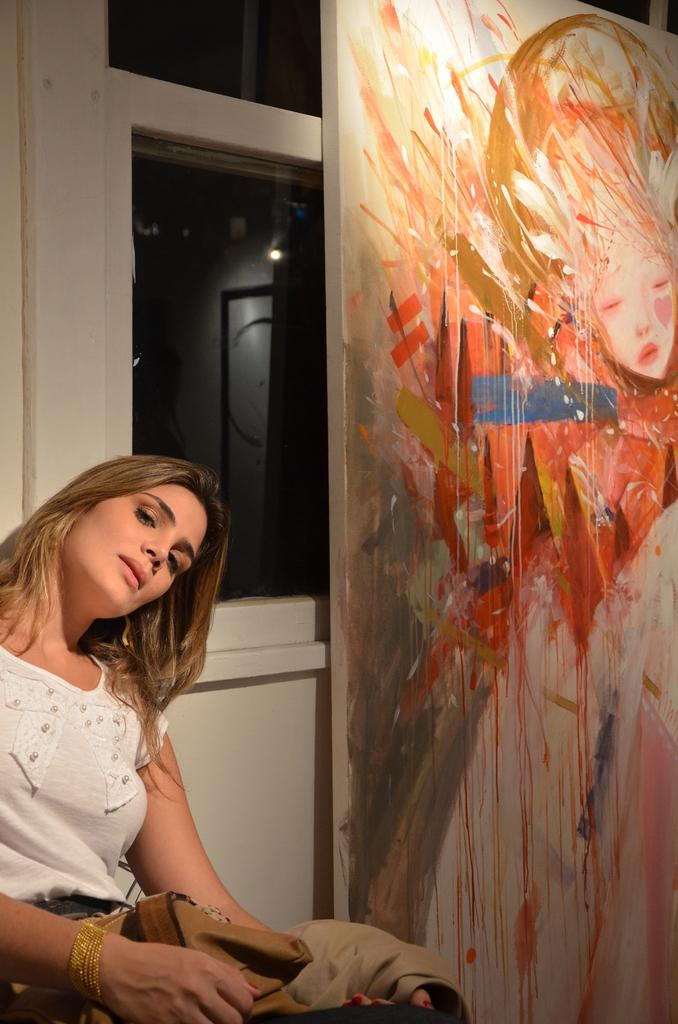What is the woman doing in the room? The woman is sitting in the room. What is the woman holding in her hand? The woman is holding an object on the left side. What can be seen on the right side of the room? There is a board with a painting on the right side. How many babies are present in the room? There is no mention of babies in the image, so it cannot be determined if any are present. 